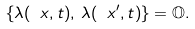<formula> <loc_0><loc_0><loc_500><loc_500>\{ \lambda ( \ x , t ) , \, \lambda ( \ x ^ { \prime } , t ) \} = \mathbb { O } .</formula> 